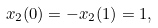<formula> <loc_0><loc_0><loc_500><loc_500>{ x _ { 2 } } ( 0 ) = - { x _ { 2 } } ( 1 ) = 1 ,</formula> 